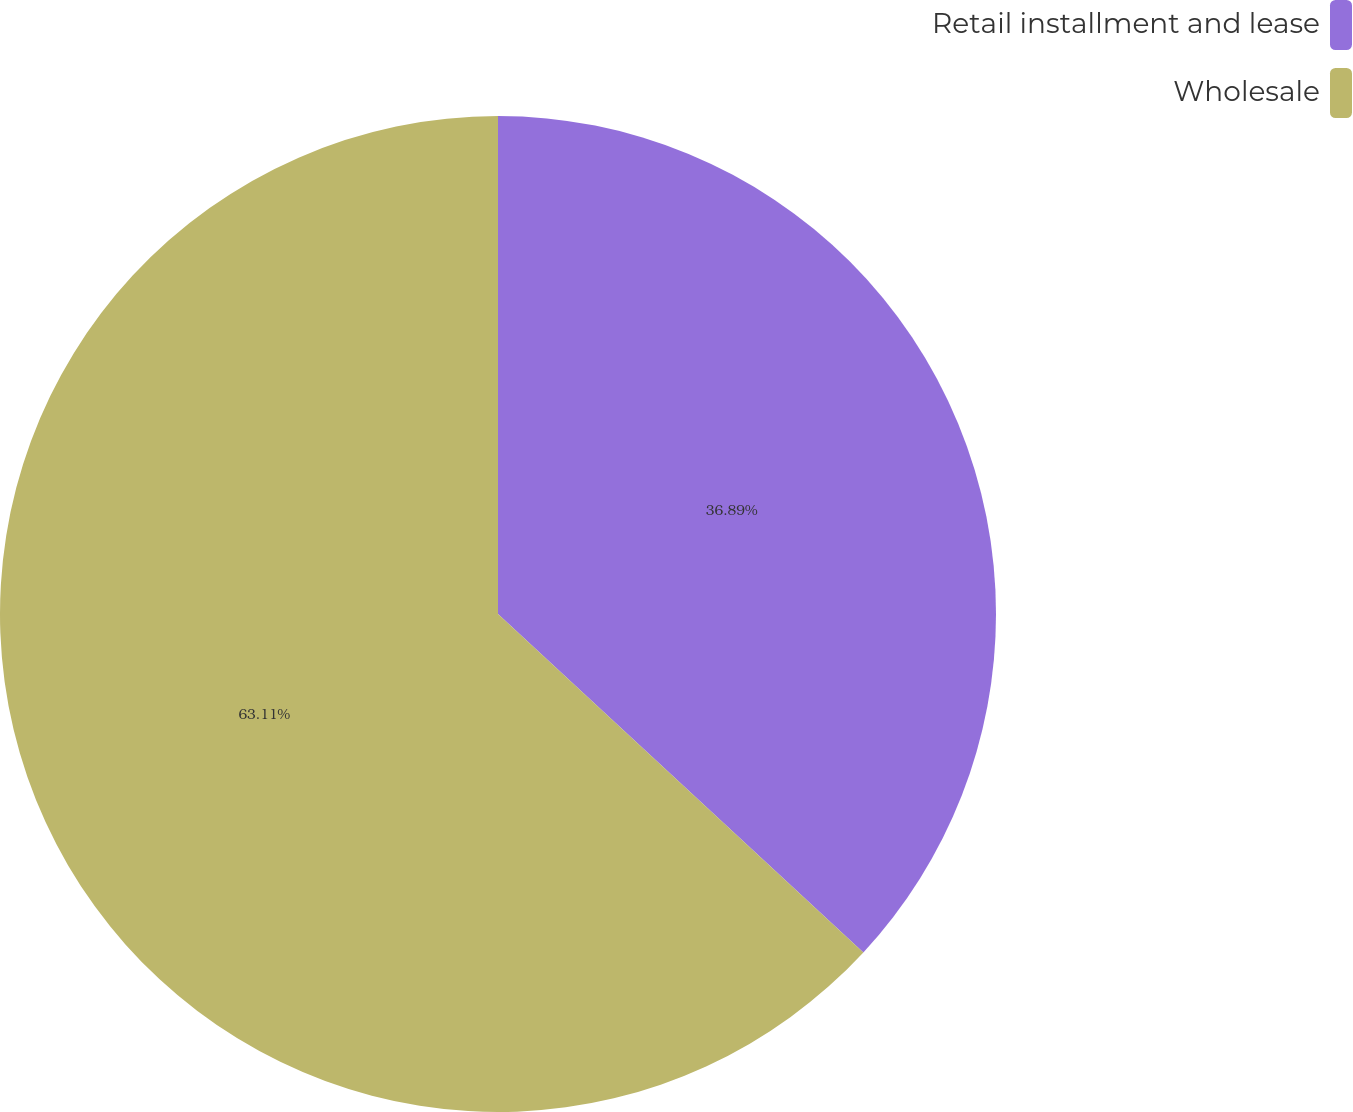Convert chart to OTSL. <chart><loc_0><loc_0><loc_500><loc_500><pie_chart><fcel>Retail installment and lease<fcel>Wholesale<nl><fcel>36.89%<fcel>63.11%<nl></chart> 